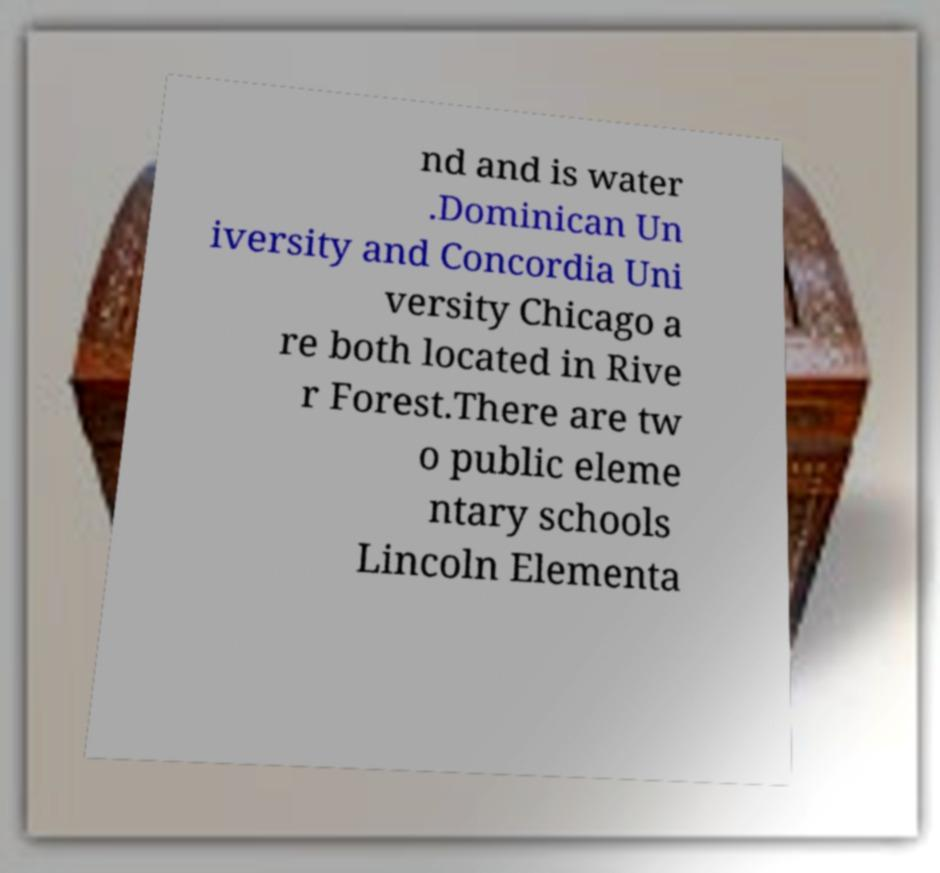What messages or text are displayed in this image? I need them in a readable, typed format. nd and is water .Dominican Un iversity and Concordia Uni versity Chicago a re both located in Rive r Forest.There are tw o public eleme ntary schools Lincoln Elementa 